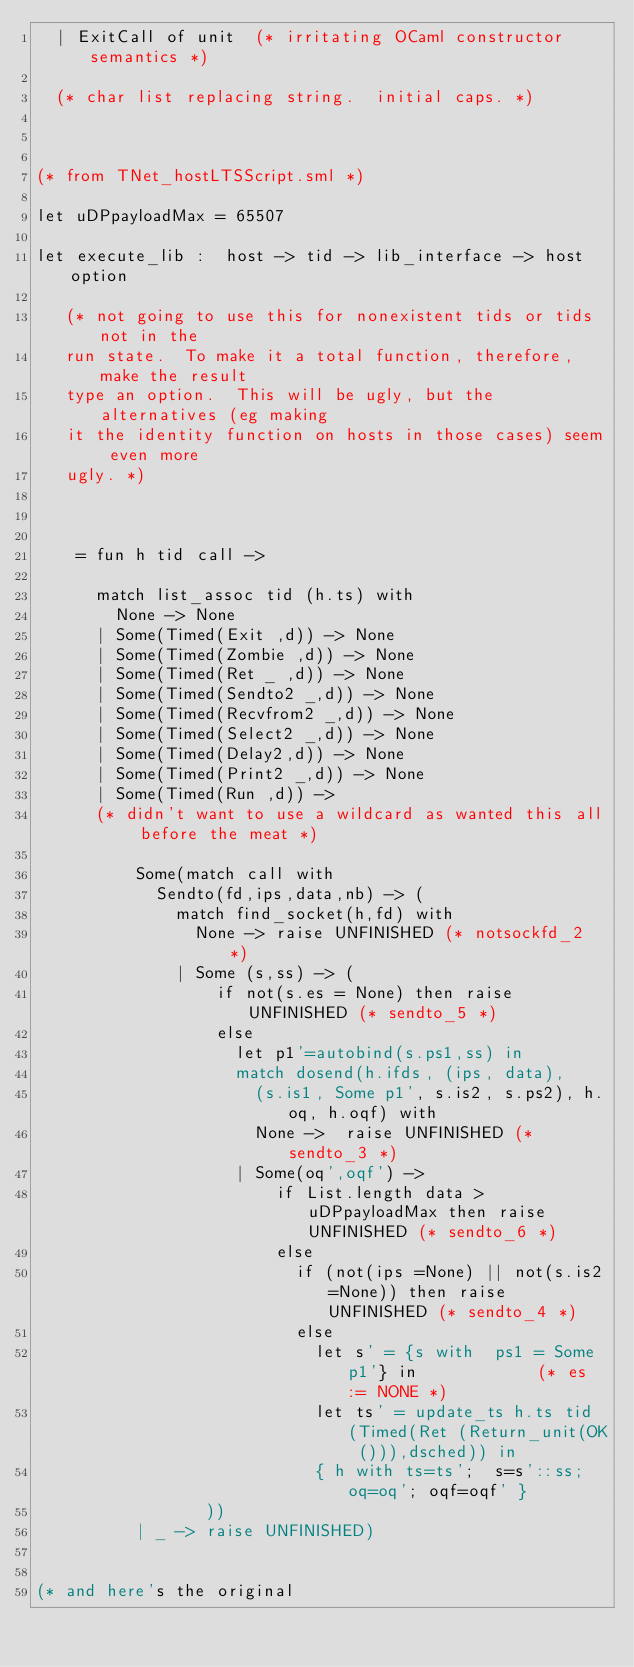<code> <loc_0><loc_0><loc_500><loc_500><_OCaml_>  | ExitCall of unit  (* irritating OCaml constructor semantics *)

  (* char list replacing string.  initial caps. *)



(* from TNet_hostLTSScript.sml *)

let uDPpayloadMax = 65507

let execute_lib :  host -> tid -> lib_interface -> host option

   (* not going to use this for nonexistent tids or tids not in the
   run state.  To make it a total function, therefore, make the result
   type an option.  This will be ugly, but the alternatives (eg making
   it the identity function on hosts in those cases) seem even more
   ugly. *)



    = fun h tid call -> 

      match list_assoc tid (h.ts) with
        None -> None
      | Some(Timed(Exit ,d)) -> None
      | Some(Timed(Zombie ,d)) -> None
      | Some(Timed(Ret _ ,d)) -> None
      | Some(Timed(Sendto2 _,d)) -> None
      | Some(Timed(Recvfrom2 _,d)) -> None
      | Some(Timed(Select2 _,d)) -> None
      | Some(Timed(Delay2,d)) -> None
      | Some(Timed(Print2 _,d)) -> None
      | Some(Timed(Run ,d)) -> 
      (* didn't want to use a wildcard as wanted this all before the meat *)

          Some(match call with 
            Sendto(fd,ips,data,nb) -> (
              match find_socket(h,fd) with
                None -> raise UNFINISHED (* notsockfd_2 *)
              | Some (s,ss) -> (
                  if not(s.es = None) then raise UNFINISHED (* sendto_5 *)
                  else
                    let p1'=autobind(s.ps1,ss) in
                    match dosend(h.ifds, (ips, data),
                      (s.is1, Some p1', s.is2, s.ps2), h.oq, h.oqf) with
                      None ->  raise UNFINISHED (* sendto_3 *)
                    | Some(oq',oqf') -> 
                        if List.length data > uDPpayloadMax then raise UNFINISHED (* sendto_6 *)
                        else
                          if (not(ips =None) || not(s.is2=None)) then raise UNFINISHED (* sendto_4 *)
                          else
                            let s' = {s with  ps1 = Some p1'} in            (* es := NONE *)
                            let ts' = update_ts h.ts tid (Timed(Ret (Return_unit(OK ())),dsched)) in
                            { h with ts=ts';  s=s'::ss; oq=oq'; oqf=oqf' }
                 ))
          | _ -> raise UNFINISHED)
     

(* and here's the original 
</code> 